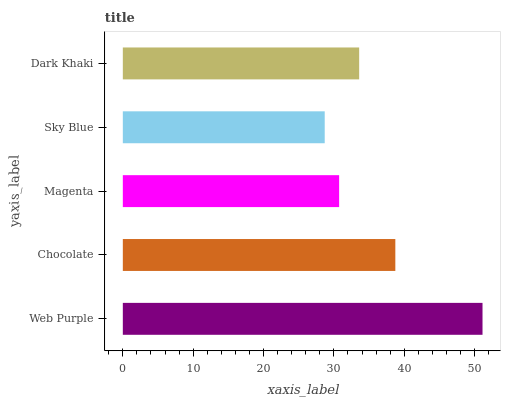Is Sky Blue the minimum?
Answer yes or no. Yes. Is Web Purple the maximum?
Answer yes or no. Yes. Is Chocolate the minimum?
Answer yes or no. No. Is Chocolate the maximum?
Answer yes or no. No. Is Web Purple greater than Chocolate?
Answer yes or no. Yes. Is Chocolate less than Web Purple?
Answer yes or no. Yes. Is Chocolate greater than Web Purple?
Answer yes or no. No. Is Web Purple less than Chocolate?
Answer yes or no. No. Is Dark Khaki the high median?
Answer yes or no. Yes. Is Dark Khaki the low median?
Answer yes or no. Yes. Is Web Purple the high median?
Answer yes or no. No. Is Chocolate the low median?
Answer yes or no. No. 